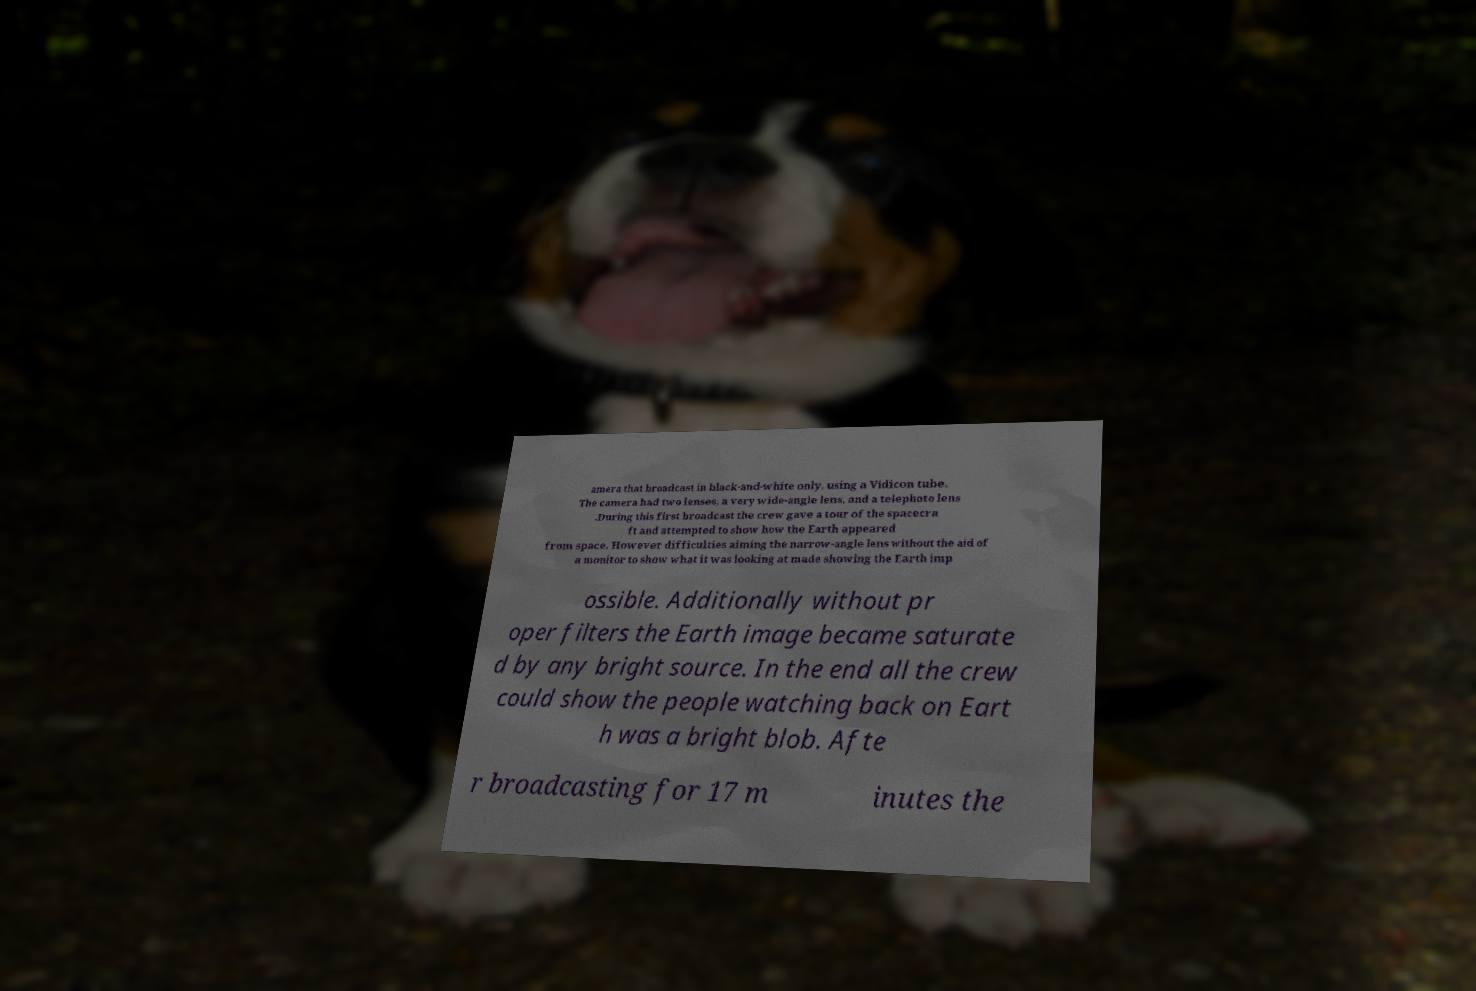Please identify and transcribe the text found in this image. amera that broadcast in black-and-white only, using a Vidicon tube. The camera had two lenses, a very wide-angle lens, and a telephoto lens .During this first broadcast the crew gave a tour of the spacecra ft and attempted to show how the Earth appeared from space. However difficulties aiming the narrow-angle lens without the aid of a monitor to show what it was looking at made showing the Earth imp ossible. Additionally without pr oper filters the Earth image became saturate d by any bright source. In the end all the crew could show the people watching back on Eart h was a bright blob. Afte r broadcasting for 17 m inutes the 